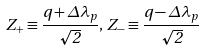Convert formula to latex. <formula><loc_0><loc_0><loc_500><loc_500>Z _ { + } \equiv \frac { q + \Delta \lambda _ { p } } { \sqrt { 2 } } , \, Z _ { - } \equiv \frac { q - \Delta \lambda _ { p } } { \sqrt { 2 } }</formula> 